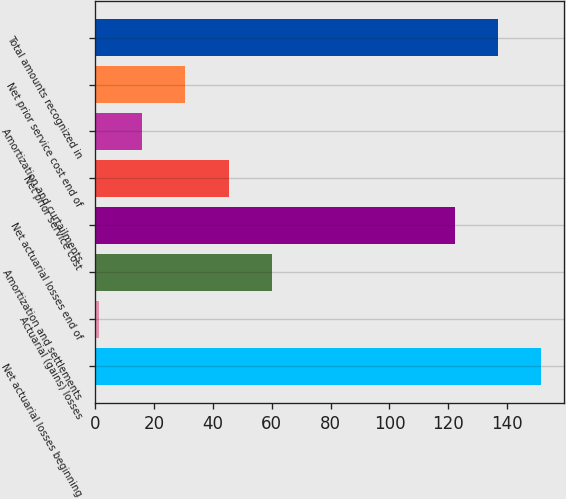Convert chart to OTSL. <chart><loc_0><loc_0><loc_500><loc_500><bar_chart><fcel>Net actuarial losses beginning<fcel>Actuarial (gains) losses<fcel>Amortization and settlements<fcel>Net actuarial losses end of<fcel>Net prior service cost<fcel>Amortization and curtailments<fcel>Net prior service cost end of<fcel>Total amounts recognized in<nl><fcel>151.6<fcel>1.2<fcel>60<fcel>122.2<fcel>45.3<fcel>15.9<fcel>30.6<fcel>136.9<nl></chart> 